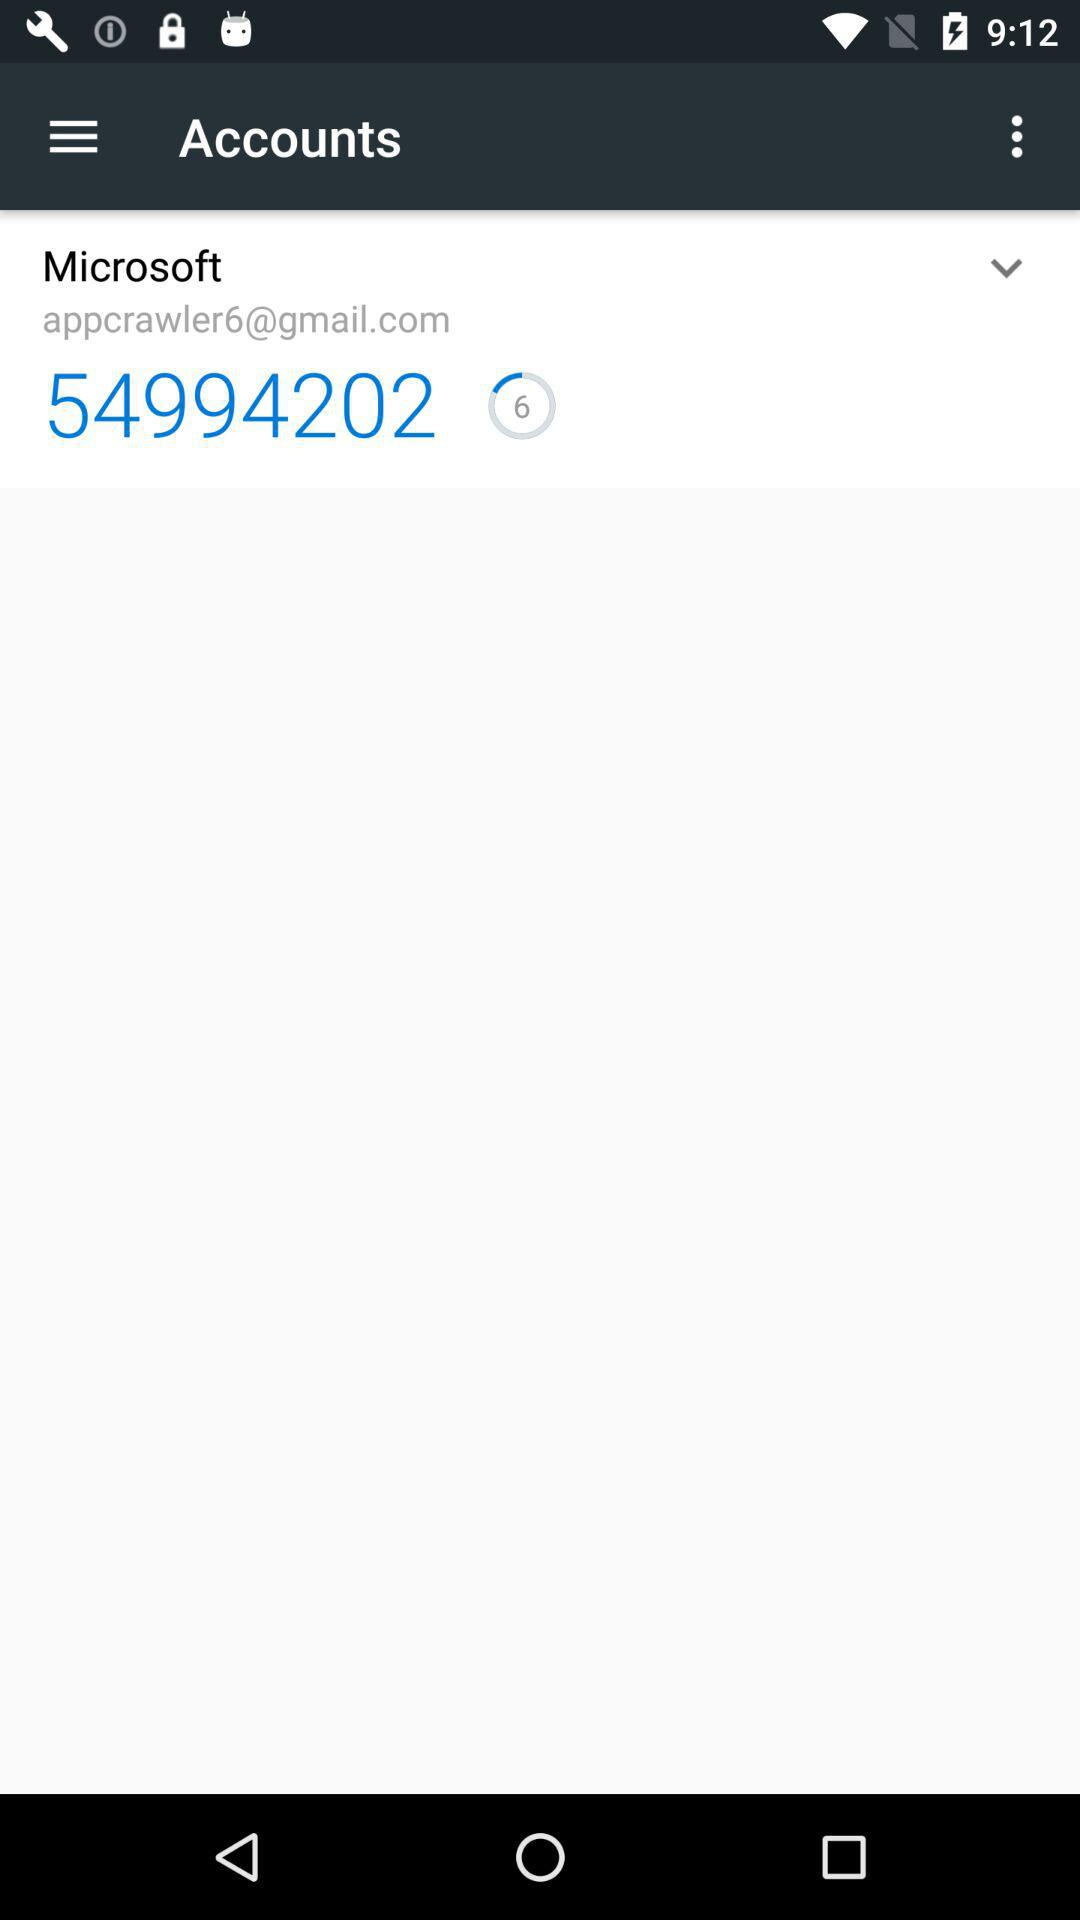What is the identity number? The number is 54994202. 